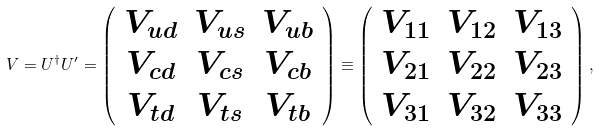Convert formula to latex. <formula><loc_0><loc_0><loc_500><loc_500>V = U ^ { \dagger } U ^ { \prime } = \left ( \begin{array} { c c c } V _ { u d } & V _ { u s } & V _ { u b } \\ V _ { c d } & V _ { c s } & V _ { c b } \\ V _ { t d } & V _ { t s } & V _ { t b } \end{array} \right ) \equiv \left ( \begin{array} { c c c } V _ { 1 1 } & V _ { 1 2 } & V _ { 1 3 } \\ V _ { 2 1 } & V _ { 2 2 } & V _ { 2 3 } \\ V _ { 3 1 } & V _ { 3 2 } & V _ { 3 3 } \end{array} \right ) ,</formula> 